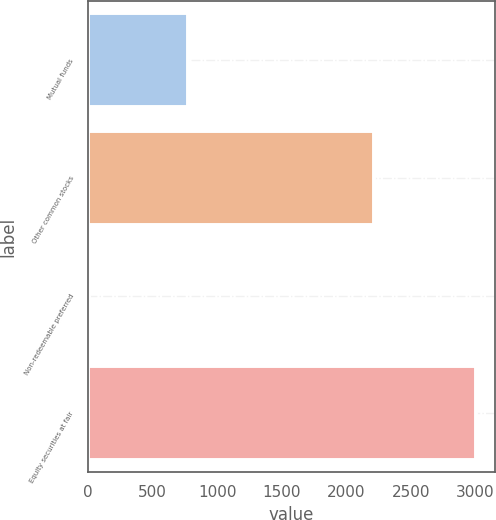Convert chart to OTSL. <chart><loc_0><loc_0><loc_500><loc_500><bar_chart><fcel>Mutual funds<fcel>Other common stocks<fcel>Non-redeemable preferred<fcel>Equity securities at fair<nl><fcel>778<fcel>2215<fcel>11<fcel>3004<nl></chart> 